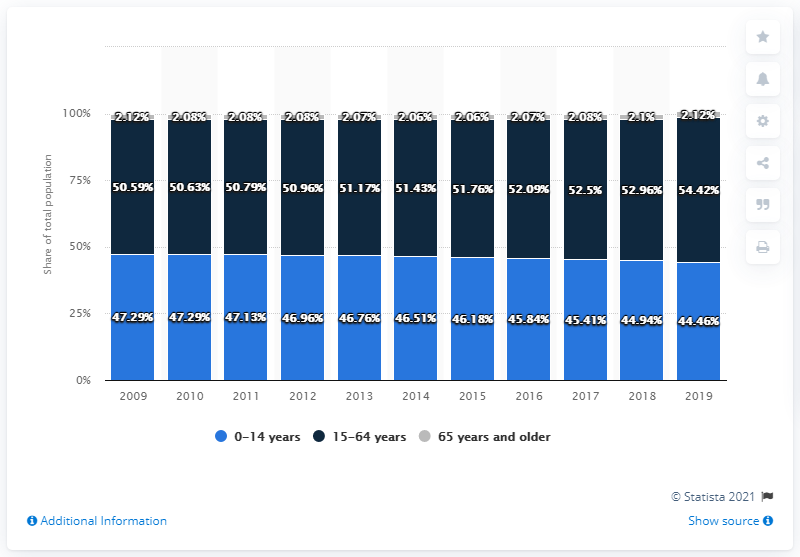Point out several critical features in this image. The percentage difference between the highest number of people in the age group 0-14 years and 15-64 years over the years is 7.13%. The highest value of navy blue bar over the years is 54.42. 